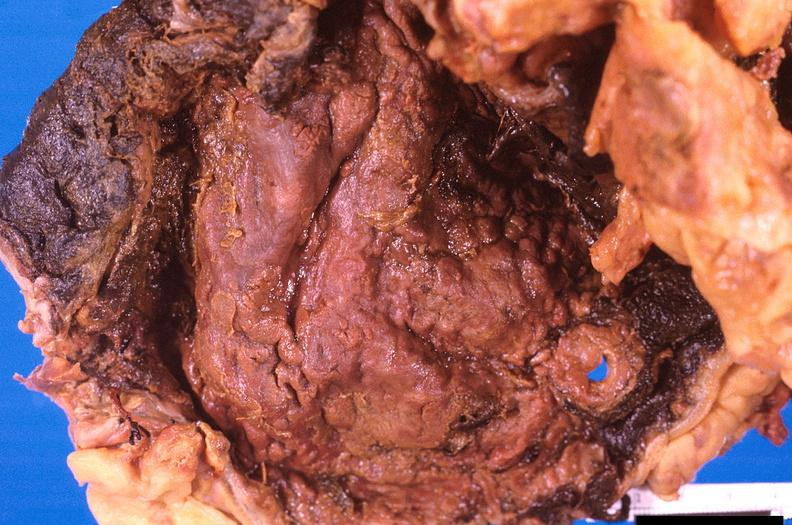what is present?
Answer the question using a single word or phrase. Gastrointestinal 